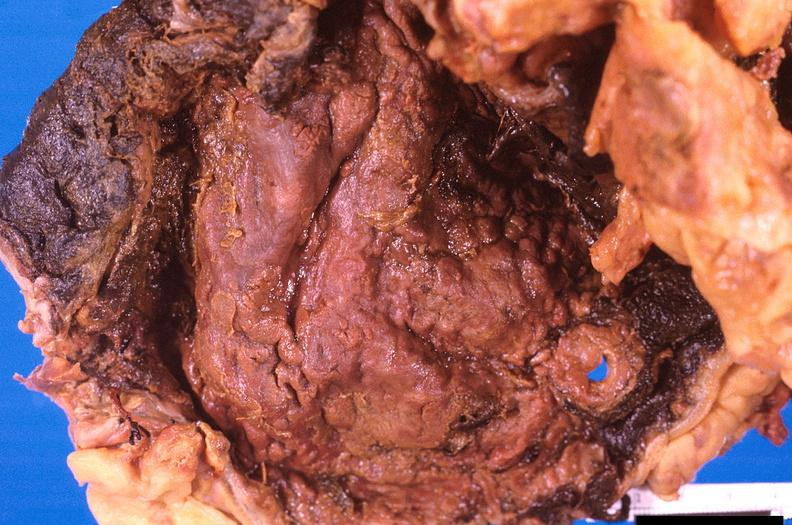what is present?
Answer the question using a single word or phrase. Gastrointestinal 